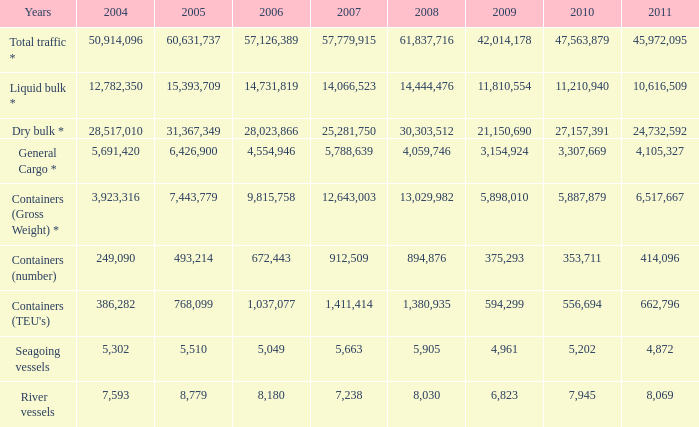Parse the table in full. {'header': ['Years', '2004', '2005', '2006', '2007', '2008', '2009', '2010', '2011'], 'rows': [['Total traffic *', '50,914,096', '60,631,737', '57,126,389', '57,779,915', '61,837,716', '42,014,178', '47,563,879', '45,972,095'], ['Liquid bulk *', '12,782,350', '15,393,709', '14,731,819', '14,066,523', '14,444,476', '11,810,554', '11,210,940', '10,616,509'], ['Dry bulk *', '28,517,010', '31,367,349', '28,023,866', '25,281,750', '30,303,512', '21,150,690', '27,157,391', '24,732,592'], ['General Cargo *', '5,691,420', '6,426,900', '4,554,946', '5,788,639', '4,059,746', '3,154,924', '3,307,669', '4,105,327'], ['Containers (Gross Weight) *', '3,923,316', '7,443,779', '9,815,758', '12,643,003', '13,029,982', '5,898,010', '5,887,879', '6,517,667'], ['Containers (number)', '249,090', '493,214', '672,443', '912,509', '894,876', '375,293', '353,711', '414,096'], ["Containers (TEU's)", '386,282', '768,099', '1,037,077', '1,411,414', '1,380,935', '594,299', '556,694', '662,796'], ['Seagoing vessels', '5,302', '5,510', '5,049', '5,663', '5,905', '4,961', '5,202', '4,872'], ['River vessels', '7,593', '8,779', '8,180', '7,238', '8,030', '6,823', '7,945', '8,069']]} What is the least figure in 2007 when 2009 is 42,014,178 and 2008 is greater than 61,837,716? None. 